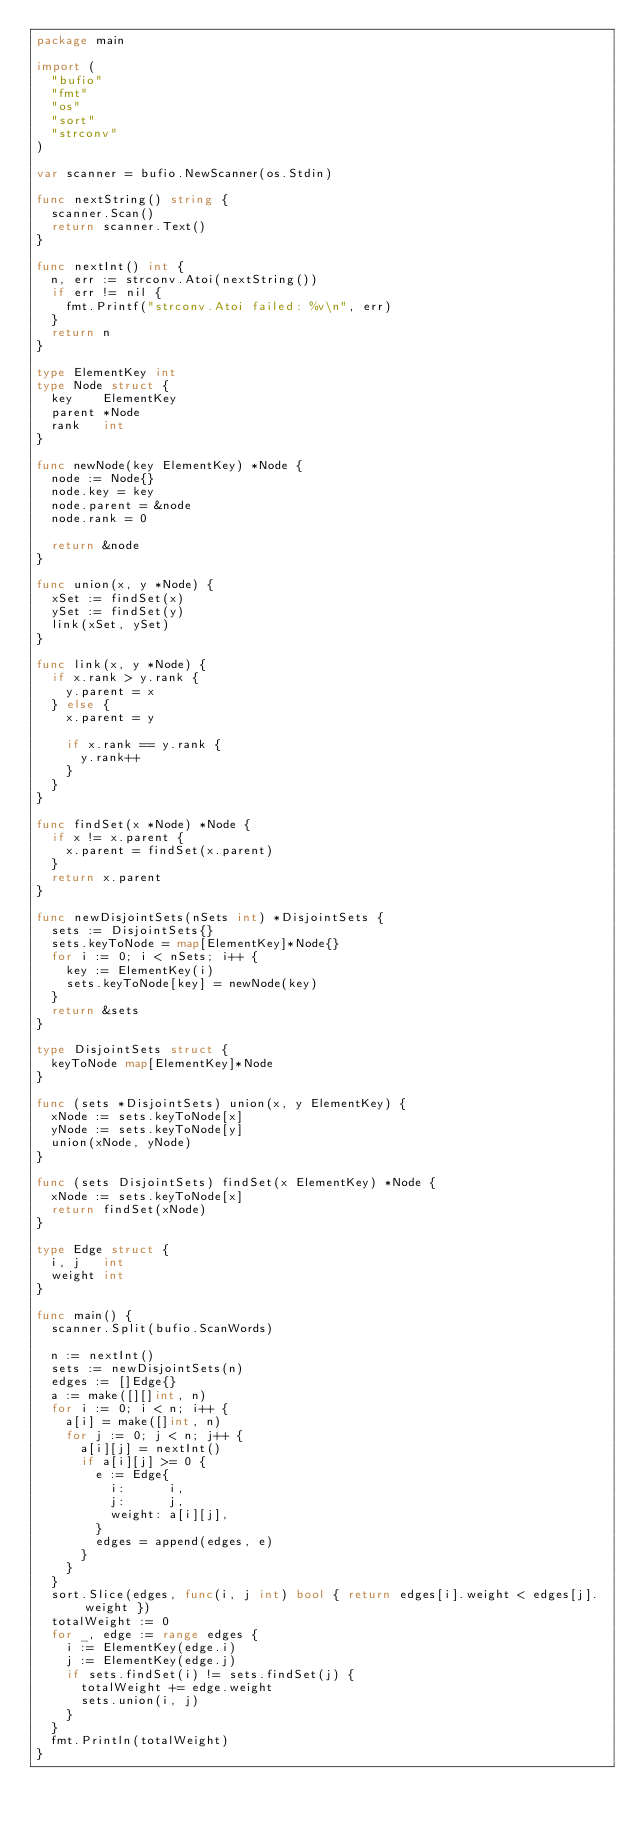Convert code to text. <code><loc_0><loc_0><loc_500><loc_500><_Go_>package main

import (
	"bufio"
	"fmt"
	"os"
	"sort"
	"strconv"
)

var scanner = bufio.NewScanner(os.Stdin)

func nextString() string {
	scanner.Scan()
	return scanner.Text()
}

func nextInt() int {
	n, err := strconv.Atoi(nextString())
	if err != nil {
		fmt.Printf("strconv.Atoi failed: %v\n", err)
	}
	return n
}

type ElementKey int
type Node struct {
	key    ElementKey
	parent *Node
	rank   int
}

func newNode(key ElementKey) *Node {
	node := Node{}
	node.key = key
	node.parent = &node
	node.rank = 0

	return &node
}

func union(x, y *Node) {
	xSet := findSet(x)
	ySet := findSet(y)
	link(xSet, ySet)
}

func link(x, y *Node) {
	if x.rank > y.rank {
		y.parent = x
	} else {
		x.parent = y

		if x.rank == y.rank {
			y.rank++
		}
	}
}

func findSet(x *Node) *Node {
	if x != x.parent {
		x.parent = findSet(x.parent)
	}
	return x.parent
}

func newDisjointSets(nSets int) *DisjointSets {
	sets := DisjointSets{}
	sets.keyToNode = map[ElementKey]*Node{}
	for i := 0; i < nSets; i++ {
		key := ElementKey(i)
		sets.keyToNode[key] = newNode(key)
	}
	return &sets
}

type DisjointSets struct {
	keyToNode map[ElementKey]*Node
}

func (sets *DisjointSets) union(x, y ElementKey) {
	xNode := sets.keyToNode[x]
	yNode := sets.keyToNode[y]
	union(xNode, yNode)
}

func (sets DisjointSets) findSet(x ElementKey) *Node {
	xNode := sets.keyToNode[x]
	return findSet(xNode)
}

type Edge struct {
	i, j   int
	weight int
}

func main() {
	scanner.Split(bufio.ScanWords)

	n := nextInt()
	sets := newDisjointSets(n)
	edges := []Edge{}
	a := make([][]int, n)
	for i := 0; i < n; i++ {
		a[i] = make([]int, n)
		for j := 0; j < n; j++ {
			a[i][j] = nextInt()
			if a[i][j] >= 0 {
				e := Edge{
					i:      i,
					j:      j,
					weight: a[i][j],
				}
				edges = append(edges, e)
			}
		}
	}
	sort.Slice(edges, func(i, j int) bool { return edges[i].weight < edges[j].weight })
	totalWeight := 0
	for _, edge := range edges {
		i := ElementKey(edge.i)
		j := ElementKey(edge.j)
		if sets.findSet(i) != sets.findSet(j) {
			totalWeight += edge.weight
			sets.union(i, j)
		}
	}
	fmt.Println(totalWeight)
}

</code> 